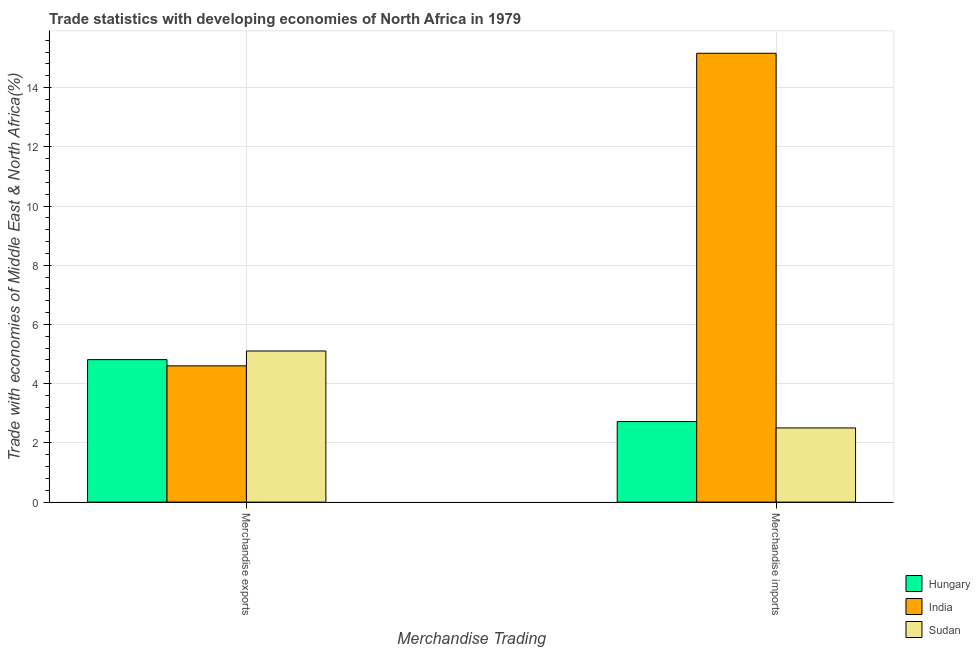How many different coloured bars are there?
Offer a terse response. 3. Are the number of bars on each tick of the X-axis equal?
Provide a succinct answer. Yes. How many bars are there on the 2nd tick from the right?
Your answer should be very brief. 3. What is the merchandise exports in Hungary?
Provide a succinct answer. 4.81. Across all countries, what is the maximum merchandise exports?
Provide a short and direct response. 5.1. Across all countries, what is the minimum merchandise exports?
Your response must be concise. 4.6. In which country was the merchandise exports maximum?
Keep it short and to the point. Sudan. In which country was the merchandise exports minimum?
Give a very brief answer. India. What is the total merchandise exports in the graph?
Provide a succinct answer. 14.52. What is the difference between the merchandise exports in Hungary and that in India?
Your answer should be very brief. 0.21. What is the difference between the merchandise exports in India and the merchandise imports in Sudan?
Keep it short and to the point. 2.1. What is the average merchandise imports per country?
Provide a succinct answer. 6.8. What is the difference between the merchandise exports and merchandise imports in India?
Make the answer very short. -10.56. What is the ratio of the merchandise imports in Hungary to that in Sudan?
Your answer should be compact. 1.09. What does the 1st bar from the left in Merchandise exports represents?
Keep it short and to the point. Hungary. What does the 2nd bar from the right in Merchandise imports represents?
Your response must be concise. India. Are all the bars in the graph horizontal?
Keep it short and to the point. No. What is the difference between two consecutive major ticks on the Y-axis?
Ensure brevity in your answer.  2. Does the graph contain any zero values?
Provide a succinct answer. No. How many legend labels are there?
Provide a succinct answer. 3. What is the title of the graph?
Keep it short and to the point. Trade statistics with developing economies of North Africa in 1979. Does "Senegal" appear as one of the legend labels in the graph?
Provide a succinct answer. No. What is the label or title of the X-axis?
Your answer should be compact. Merchandise Trading. What is the label or title of the Y-axis?
Give a very brief answer. Trade with economies of Middle East & North Africa(%). What is the Trade with economies of Middle East & North Africa(%) in Hungary in Merchandise exports?
Your response must be concise. 4.81. What is the Trade with economies of Middle East & North Africa(%) in India in Merchandise exports?
Make the answer very short. 4.6. What is the Trade with economies of Middle East & North Africa(%) in Sudan in Merchandise exports?
Ensure brevity in your answer.  5.1. What is the Trade with economies of Middle East & North Africa(%) in Hungary in Merchandise imports?
Make the answer very short. 2.72. What is the Trade with economies of Middle East & North Africa(%) of India in Merchandise imports?
Make the answer very short. 15.16. What is the Trade with economies of Middle East & North Africa(%) of Sudan in Merchandise imports?
Keep it short and to the point. 2.51. Across all Merchandise Trading, what is the maximum Trade with economies of Middle East & North Africa(%) of Hungary?
Your response must be concise. 4.81. Across all Merchandise Trading, what is the maximum Trade with economies of Middle East & North Africa(%) in India?
Your answer should be compact. 15.16. Across all Merchandise Trading, what is the maximum Trade with economies of Middle East & North Africa(%) of Sudan?
Keep it short and to the point. 5.1. Across all Merchandise Trading, what is the minimum Trade with economies of Middle East & North Africa(%) of Hungary?
Your response must be concise. 2.72. Across all Merchandise Trading, what is the minimum Trade with economies of Middle East & North Africa(%) in India?
Keep it short and to the point. 4.6. Across all Merchandise Trading, what is the minimum Trade with economies of Middle East & North Africa(%) in Sudan?
Make the answer very short. 2.51. What is the total Trade with economies of Middle East & North Africa(%) of Hungary in the graph?
Your response must be concise. 7.53. What is the total Trade with economies of Middle East & North Africa(%) in India in the graph?
Your answer should be very brief. 19.76. What is the total Trade with economies of Middle East & North Africa(%) in Sudan in the graph?
Keep it short and to the point. 7.61. What is the difference between the Trade with economies of Middle East & North Africa(%) of Hungary in Merchandise exports and that in Merchandise imports?
Your answer should be compact. 2.09. What is the difference between the Trade with economies of Middle East & North Africa(%) in India in Merchandise exports and that in Merchandise imports?
Offer a terse response. -10.56. What is the difference between the Trade with economies of Middle East & North Africa(%) of Sudan in Merchandise exports and that in Merchandise imports?
Give a very brief answer. 2.6. What is the difference between the Trade with economies of Middle East & North Africa(%) of Hungary in Merchandise exports and the Trade with economies of Middle East & North Africa(%) of India in Merchandise imports?
Offer a very short reply. -10.35. What is the difference between the Trade with economies of Middle East & North Africa(%) of Hungary in Merchandise exports and the Trade with economies of Middle East & North Africa(%) of Sudan in Merchandise imports?
Provide a short and direct response. 2.31. What is the difference between the Trade with economies of Middle East & North Africa(%) of India in Merchandise exports and the Trade with economies of Middle East & North Africa(%) of Sudan in Merchandise imports?
Your response must be concise. 2.1. What is the average Trade with economies of Middle East & North Africa(%) of Hungary per Merchandise Trading?
Provide a succinct answer. 3.77. What is the average Trade with economies of Middle East & North Africa(%) in India per Merchandise Trading?
Ensure brevity in your answer.  9.88. What is the average Trade with economies of Middle East & North Africa(%) in Sudan per Merchandise Trading?
Provide a short and direct response. 3.8. What is the difference between the Trade with economies of Middle East & North Africa(%) of Hungary and Trade with economies of Middle East & North Africa(%) of India in Merchandise exports?
Keep it short and to the point. 0.21. What is the difference between the Trade with economies of Middle East & North Africa(%) in Hungary and Trade with economies of Middle East & North Africa(%) in Sudan in Merchandise exports?
Make the answer very short. -0.29. What is the difference between the Trade with economies of Middle East & North Africa(%) of India and Trade with economies of Middle East & North Africa(%) of Sudan in Merchandise exports?
Offer a terse response. -0.5. What is the difference between the Trade with economies of Middle East & North Africa(%) of Hungary and Trade with economies of Middle East & North Africa(%) of India in Merchandise imports?
Offer a very short reply. -12.44. What is the difference between the Trade with economies of Middle East & North Africa(%) of Hungary and Trade with economies of Middle East & North Africa(%) of Sudan in Merchandise imports?
Offer a terse response. 0.22. What is the difference between the Trade with economies of Middle East & North Africa(%) in India and Trade with economies of Middle East & North Africa(%) in Sudan in Merchandise imports?
Offer a terse response. 12.65. What is the ratio of the Trade with economies of Middle East & North Africa(%) of Hungary in Merchandise exports to that in Merchandise imports?
Offer a terse response. 1.77. What is the ratio of the Trade with economies of Middle East & North Africa(%) of India in Merchandise exports to that in Merchandise imports?
Your response must be concise. 0.3. What is the ratio of the Trade with economies of Middle East & North Africa(%) in Sudan in Merchandise exports to that in Merchandise imports?
Your answer should be compact. 2.04. What is the difference between the highest and the second highest Trade with economies of Middle East & North Africa(%) in Hungary?
Offer a very short reply. 2.09. What is the difference between the highest and the second highest Trade with economies of Middle East & North Africa(%) of India?
Make the answer very short. 10.56. What is the difference between the highest and the second highest Trade with economies of Middle East & North Africa(%) of Sudan?
Provide a short and direct response. 2.6. What is the difference between the highest and the lowest Trade with economies of Middle East & North Africa(%) in Hungary?
Make the answer very short. 2.09. What is the difference between the highest and the lowest Trade with economies of Middle East & North Africa(%) of India?
Give a very brief answer. 10.56. What is the difference between the highest and the lowest Trade with economies of Middle East & North Africa(%) in Sudan?
Your answer should be compact. 2.6. 